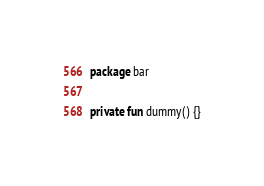Convert code to text. <code><loc_0><loc_0><loc_500><loc_500><_Kotlin_>package bar

private fun dummy() {}
</code> 